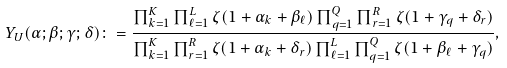Convert formula to latex. <formula><loc_0><loc_0><loc_500><loc_500>Y _ { U } ( \alpha ; \beta ; \gamma ; \delta ) \colon = \frac { \prod _ { k = 1 } ^ { K } \prod _ { \ell = 1 } ^ { L } \zeta ( 1 + \alpha _ { k } + \beta _ { \ell } ) \prod _ { q = 1 } ^ { Q } \prod _ { r = 1 } ^ { R } \zeta ( 1 + \gamma _ { q } + \delta _ { r } ) } { \prod _ { k = 1 } ^ { K } \prod _ { r = 1 } ^ { R } \zeta ( 1 + \alpha _ { k } + \delta _ { r } ) \prod _ { \ell = 1 } ^ { L } \prod _ { q = 1 } ^ { Q } \zeta ( 1 + \beta _ { \ell } + \gamma _ { q } ) } ,</formula> 